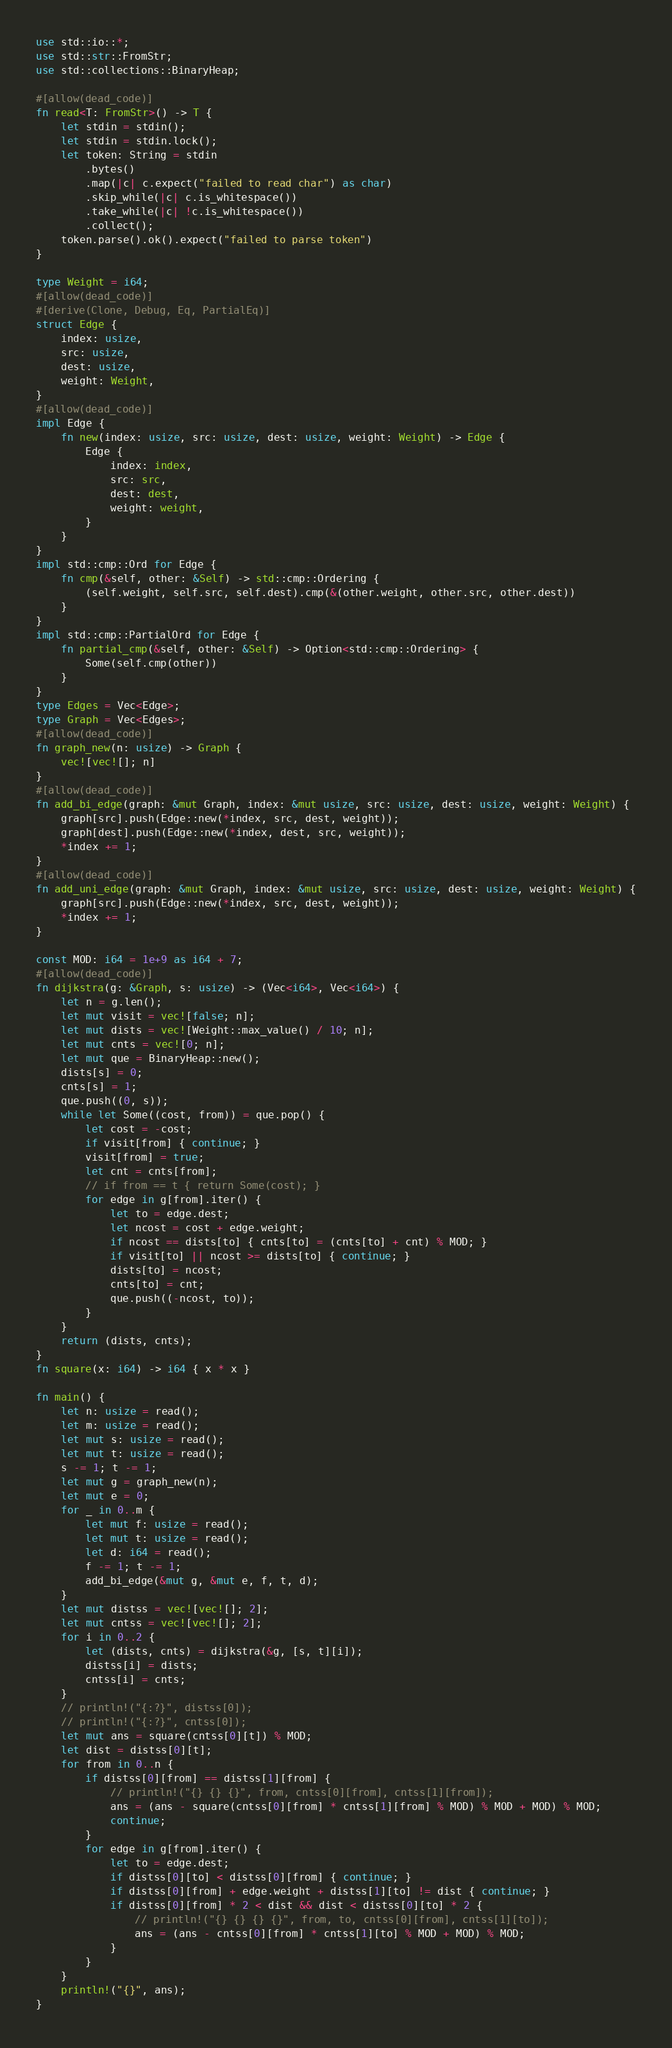Convert code to text. <code><loc_0><loc_0><loc_500><loc_500><_Rust_>use std::io::*;
use std::str::FromStr;
use std::collections::BinaryHeap;

#[allow(dead_code)]
fn read<T: FromStr>() -> T {
    let stdin = stdin();
    let stdin = stdin.lock();
    let token: String = stdin
        .bytes()
        .map(|c| c.expect("failed to read char") as char)
        .skip_while(|c| c.is_whitespace())
        .take_while(|c| !c.is_whitespace())
        .collect();
    token.parse().ok().expect("failed to parse token")
}

type Weight = i64;
#[allow(dead_code)]
#[derive(Clone, Debug, Eq, PartialEq)]
struct Edge {
    index: usize,
    src: usize,
    dest: usize,
    weight: Weight,
}
#[allow(dead_code)]
impl Edge {
    fn new(index: usize, src: usize, dest: usize, weight: Weight) -> Edge {
        Edge {
            index: index,
            src: src,
            dest: dest,
            weight: weight,
        }
    }
}
impl std::cmp::Ord for Edge {
    fn cmp(&self, other: &Self) -> std::cmp::Ordering {
        (self.weight, self.src, self.dest).cmp(&(other.weight, other.src, other.dest))
    }
}
impl std::cmp::PartialOrd for Edge {
    fn partial_cmp(&self, other: &Self) -> Option<std::cmp::Ordering> {
        Some(self.cmp(other))
    }
}
type Edges = Vec<Edge>;
type Graph = Vec<Edges>;
#[allow(dead_code)]
fn graph_new(n: usize) -> Graph {
    vec![vec![]; n]
}
#[allow(dead_code)]
fn add_bi_edge(graph: &mut Graph, index: &mut usize, src: usize, dest: usize, weight: Weight) {
    graph[src].push(Edge::new(*index, src, dest, weight));
    graph[dest].push(Edge::new(*index, dest, src, weight));
    *index += 1;
}
#[allow(dead_code)]
fn add_uni_edge(graph: &mut Graph, index: &mut usize, src: usize, dest: usize, weight: Weight) {
    graph[src].push(Edge::new(*index, src, dest, weight));
    *index += 1;
}

const MOD: i64 = 1e+9 as i64 + 7;
#[allow(dead_code)]
fn dijkstra(g: &Graph, s: usize) -> (Vec<i64>, Vec<i64>) {
    let n = g.len();
    let mut visit = vec![false; n];
    let mut dists = vec![Weight::max_value() / 10; n];
    let mut cnts = vec![0; n];
    let mut que = BinaryHeap::new();
    dists[s] = 0;
    cnts[s] = 1;
    que.push((0, s));
    while let Some((cost, from)) = que.pop() {
        let cost = -cost;
        if visit[from] { continue; }
        visit[from] = true;
        let cnt = cnts[from];
        // if from == t { return Some(cost); }
        for edge in g[from].iter() {
            let to = edge.dest;
            let ncost = cost + edge.weight;
            if ncost == dists[to] { cnts[to] = (cnts[to] + cnt) % MOD; }
            if visit[to] || ncost >= dists[to] { continue; }
            dists[to] = ncost;
            cnts[to] = cnt;
            que.push((-ncost, to));
        }
    }
    return (dists, cnts);
}
fn square(x: i64) -> i64 { x * x }

fn main() {
    let n: usize = read();
    let m: usize = read();
    let mut s: usize = read();
    let mut t: usize = read();
    s -= 1; t -= 1;
    let mut g = graph_new(n);
    let mut e = 0;
    for _ in 0..m {
        let mut f: usize = read();
        let mut t: usize = read();
        let d: i64 = read();
        f -= 1; t -= 1;
        add_bi_edge(&mut g, &mut e, f, t, d);
    }
    let mut distss = vec![vec![]; 2];
    let mut cntss = vec![vec![]; 2];
    for i in 0..2 {
        let (dists, cnts) = dijkstra(&g, [s, t][i]);
        distss[i] = dists;
        cntss[i] = cnts;
    }
    // println!("{:?}", distss[0]);
    // println!("{:?}", cntss[0]);
    let mut ans = square(cntss[0][t]) % MOD;
    let dist = distss[0][t];
    for from in 0..n {
        if distss[0][from] == distss[1][from] {
            // println!("{} {} {}", from, cntss[0][from], cntss[1][from]);
            ans = (ans - square(cntss[0][from] * cntss[1][from] % MOD) % MOD + MOD) % MOD;
            continue;
        }
        for edge in g[from].iter() {
            let to = edge.dest;
            if distss[0][to] < distss[0][from] { continue; }
            if distss[0][from] + edge.weight + distss[1][to] != dist { continue; }
            if distss[0][from] * 2 < dist && dist < distss[0][to] * 2 {
                // println!("{} {} {} {}", from, to, cntss[0][from], cntss[1][to]);
                ans = (ans - cntss[0][from] * cntss[1][to] % MOD + MOD) % MOD;
            }
        }
    }
    println!("{}", ans);
}</code> 